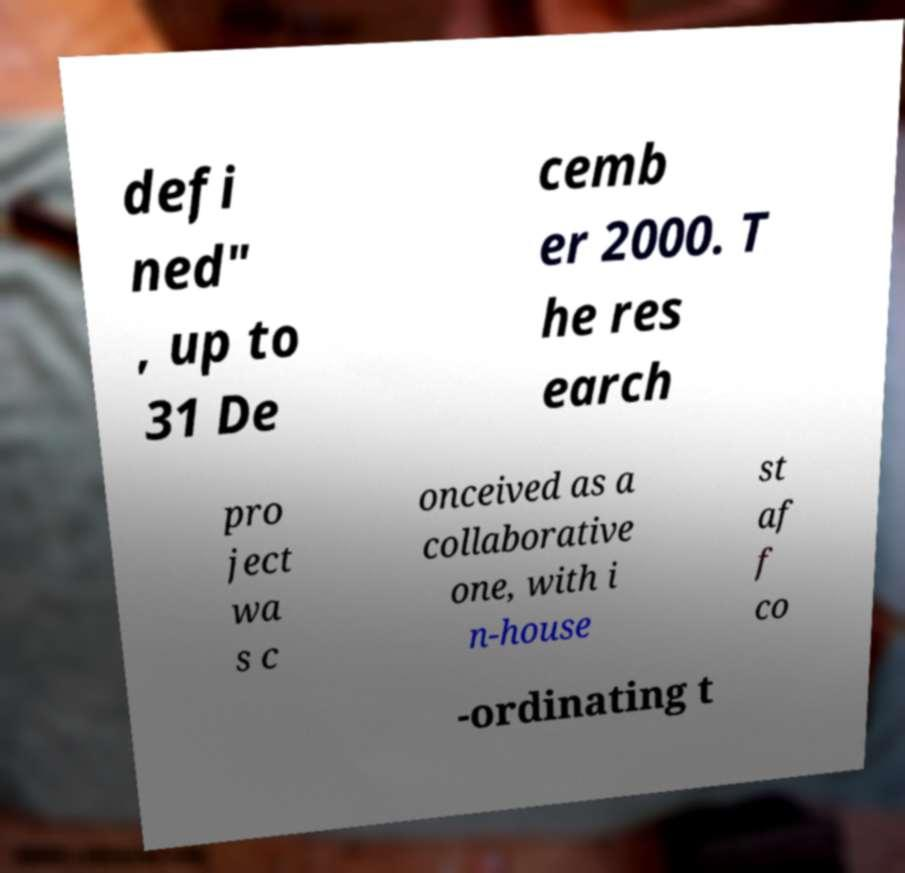Can you read and provide the text displayed in the image?This photo seems to have some interesting text. Can you extract and type it out for me? defi ned" , up to 31 De cemb er 2000. T he res earch pro ject wa s c onceived as a collaborative one, with i n-house st af f co -ordinating t 